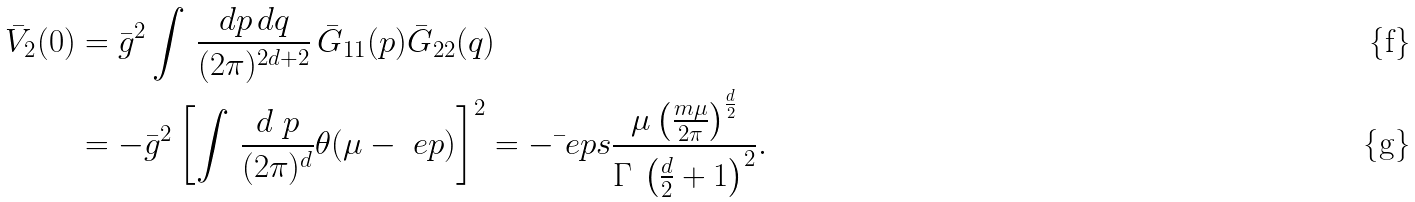<formula> <loc_0><loc_0><loc_500><loc_500>\bar { V } _ { 2 } ( 0 ) & = \bar { g } ^ { 2 } \int \, \frac { d p \, d q } { ( 2 \pi ) ^ { 2 d + 2 } } \, \bar { G } _ { 1 1 } ( p ) \bar { G } _ { 2 2 } ( q ) \\ & = - \bar { g } ^ { 2 } \left [ \int \, \frac { d \ p } { ( 2 \pi ) ^ { d } } \theta ( \mu - \ e p ) \right ] ^ { 2 } = - \bar { \ } e p s \frac { \mu \left ( \frac { m \mu } { 2 \pi } \right ) ^ { \frac { d } { 2 } } } { \Gamma \, \left ( \frac { d } { 2 } + 1 \right ) ^ { 2 } } .</formula> 